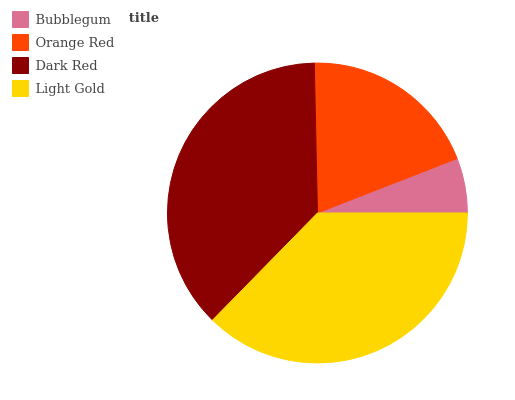Is Bubblegum the minimum?
Answer yes or no. Yes. Is Light Gold the maximum?
Answer yes or no. Yes. Is Orange Red the minimum?
Answer yes or no. No. Is Orange Red the maximum?
Answer yes or no. No. Is Orange Red greater than Bubblegum?
Answer yes or no. Yes. Is Bubblegum less than Orange Red?
Answer yes or no. Yes. Is Bubblegum greater than Orange Red?
Answer yes or no. No. Is Orange Red less than Bubblegum?
Answer yes or no. No. Is Dark Red the high median?
Answer yes or no. Yes. Is Orange Red the low median?
Answer yes or no. Yes. Is Bubblegum the high median?
Answer yes or no. No. Is Light Gold the low median?
Answer yes or no. No. 